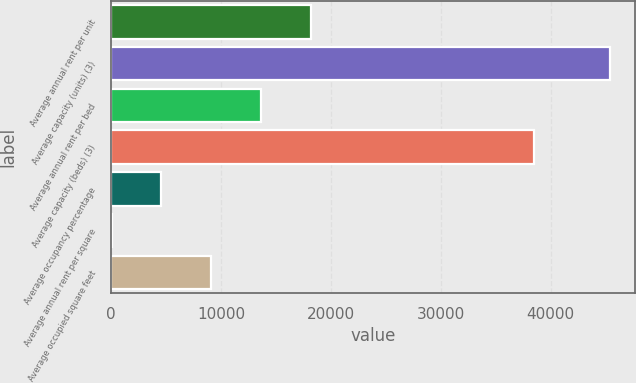Convert chart. <chart><loc_0><loc_0><loc_500><loc_500><bar_chart><fcel>Average annual rent per unit<fcel>Average capacity (units) (3)<fcel>Average annual rent per bed<fcel>Average capacity (beds) (3)<fcel>Average occupancy percentage<fcel>Average annual rent per square<fcel>Average occupied square feet<nl><fcel>18186.4<fcel>45400<fcel>13650.8<fcel>38464<fcel>4579.6<fcel>44<fcel>9115.2<nl></chart> 